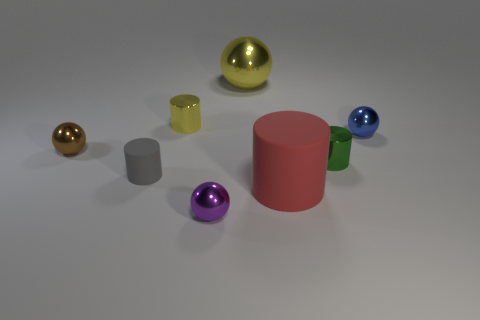Subtract all small blue spheres. How many spheres are left? 3 Add 2 tiny metal objects. How many objects exist? 10 Subtract all green cylinders. How many cylinders are left? 3 Subtract 1 gray cylinders. How many objects are left? 7 Subtract 1 balls. How many balls are left? 3 Subtract all brown spheres. Subtract all green blocks. How many spheres are left? 3 Subtract all yellow spheres. How many green cylinders are left? 1 Subtract all large cylinders. Subtract all metal balls. How many objects are left? 3 Add 1 tiny brown spheres. How many tiny brown spheres are left? 2 Add 6 small blue balls. How many small blue balls exist? 7 